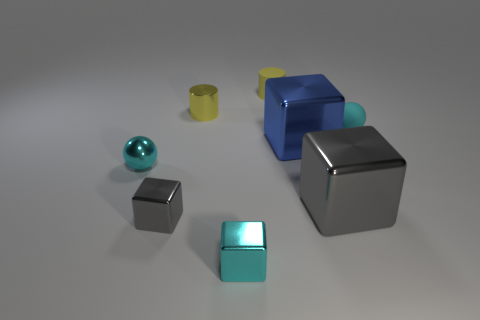Subtract all small gray metallic cubes. How many cubes are left? 3 Subtract all gray cubes. How many cubes are left? 2 Subtract 3 blocks. How many blocks are left? 1 Subtract all spheres. How many objects are left? 6 Add 2 big gray blocks. How many objects exist? 10 Subtract all big gray matte things. Subtract all tiny cyan metal spheres. How many objects are left? 7 Add 2 tiny yellow shiny things. How many tiny yellow shiny things are left? 3 Add 2 cyan shiny things. How many cyan shiny things exist? 4 Subtract 0 purple cylinders. How many objects are left? 8 Subtract all blue cubes. Subtract all green spheres. How many cubes are left? 3 